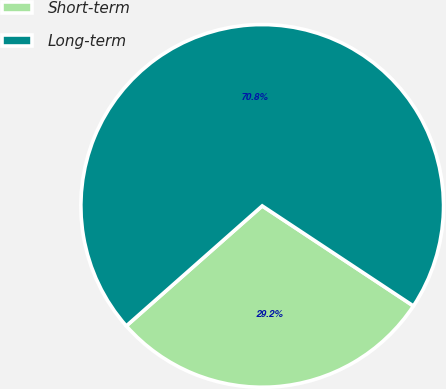<chart> <loc_0><loc_0><loc_500><loc_500><pie_chart><fcel>Short-term<fcel>Long-term<nl><fcel>29.18%<fcel>70.82%<nl></chart> 